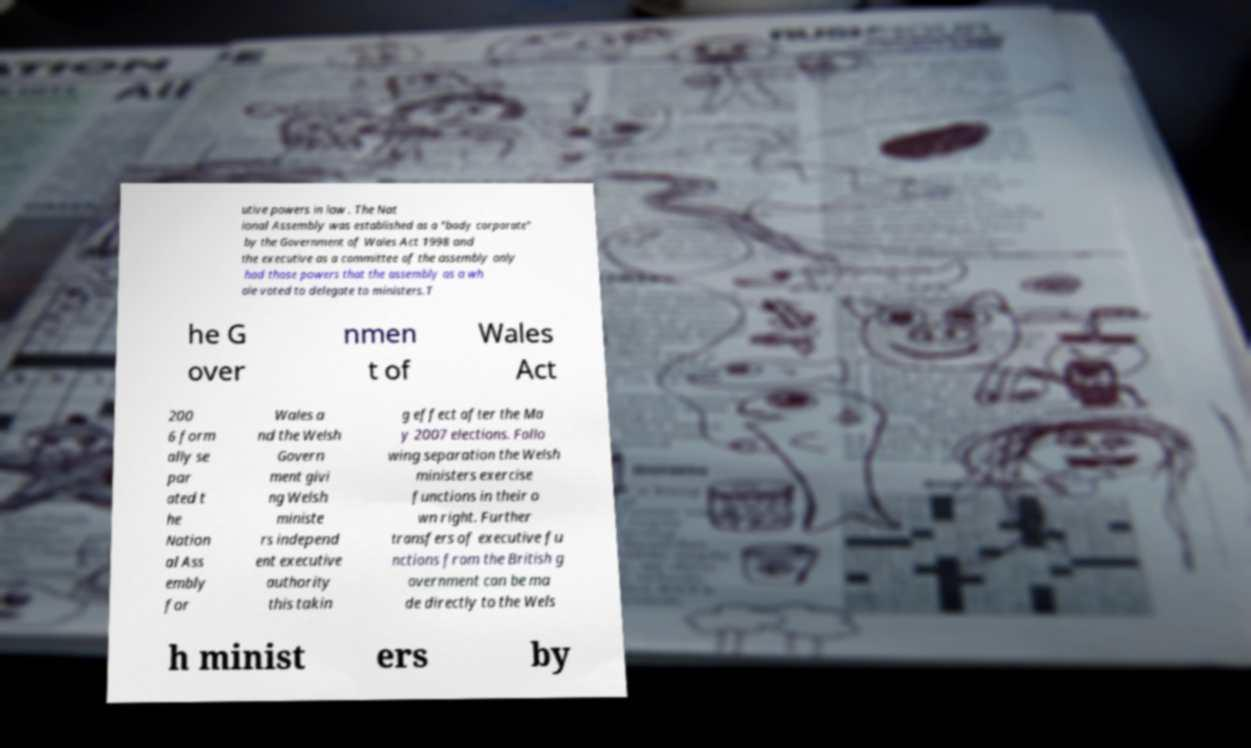There's text embedded in this image that I need extracted. Can you transcribe it verbatim? utive powers in law . The Nat ional Assembly was established as a "body corporate" by the Government of Wales Act 1998 and the executive as a committee of the assembly only had those powers that the assembly as a wh ole voted to delegate to ministers.T he G over nmen t of Wales Act 200 6 form ally se par ated t he Nation al Ass embly for Wales a nd the Welsh Govern ment givi ng Welsh ministe rs independ ent executive authority this takin g effect after the Ma y 2007 elections. Follo wing separation the Welsh ministers exercise functions in their o wn right. Further transfers of executive fu nctions from the British g overnment can be ma de directly to the Wels h minist ers by 